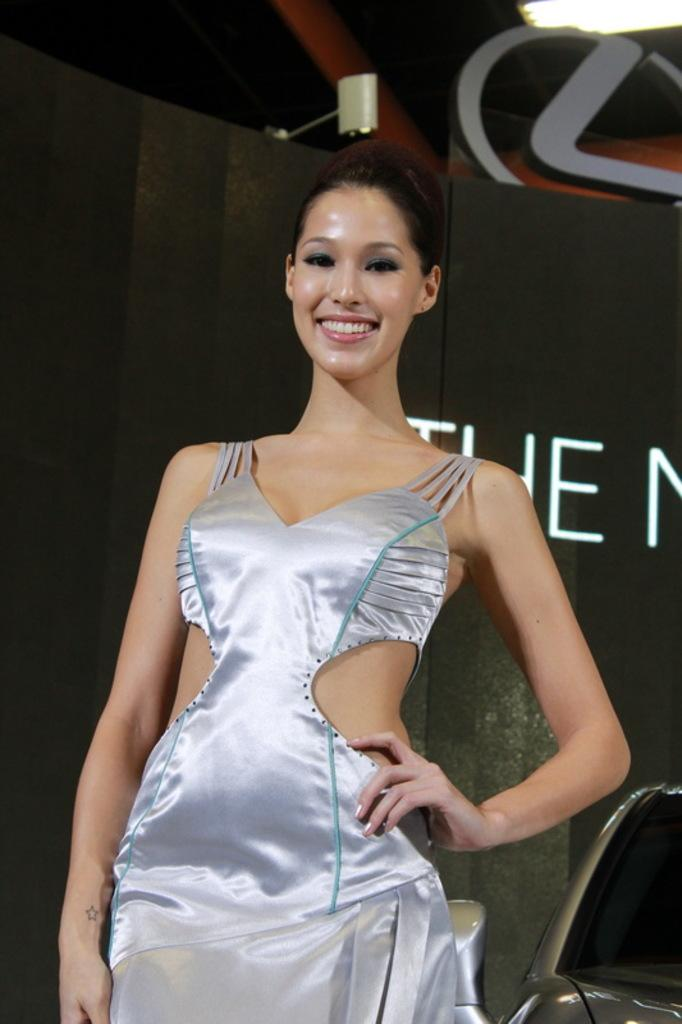Who is the main subject in the image? There is a woman standing in the front of the image. What is the woman doing in the image? The woman is smiling. What can be seen in the background of the image? There is a black color sheet in the background of the image. What is written on the sheet in the image? There is text written on the sheet. What type of shade is covering the woman in the image? There is no shade covering the woman in the image; she is standing in front of a black color sheet in the background. 